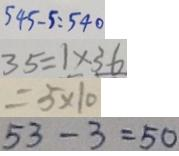Convert formula to latex. <formula><loc_0><loc_0><loc_500><loc_500>5 4 5 - 5 = 5 4 0 
 3 5 = 1 \times 3 6 
 = 5 \times 1 0 
 5 3 - 3 = 5 0</formula> 